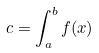<formula> <loc_0><loc_0><loc_500><loc_500>c = \int _ { a } ^ { b } f ( x )</formula> 